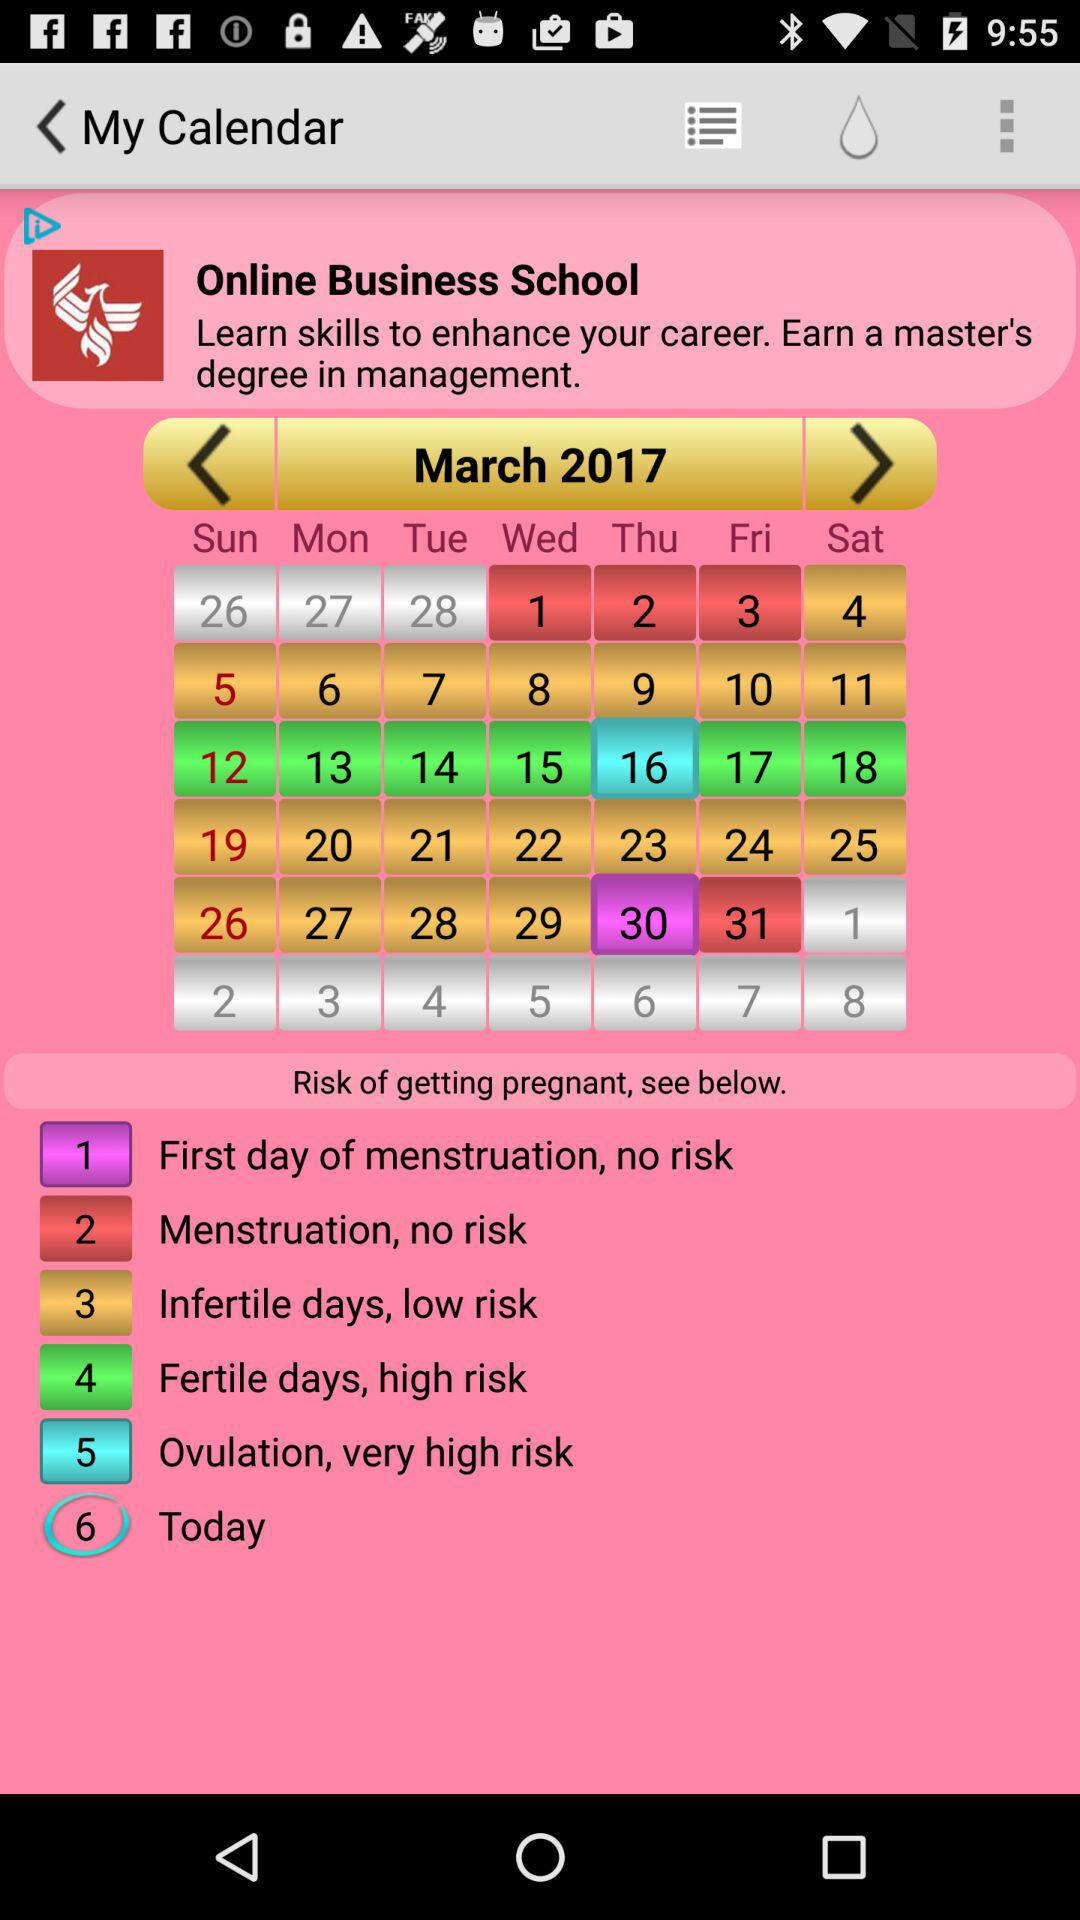What day falls on March 16, 2017? The day is Thursday. 